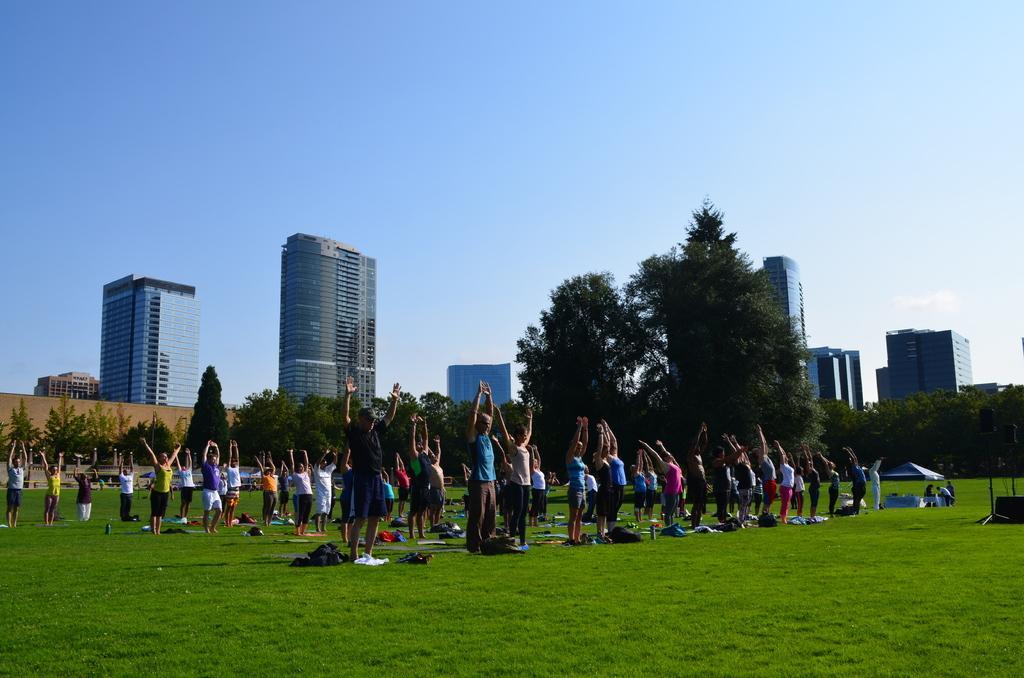Could you give a brief overview of what you see in this image? In this image I can see the ground, number of persons are standing on the ground, few clothes on the ground and a small tent. In the background I can see few trees, few buildings and the sky. 